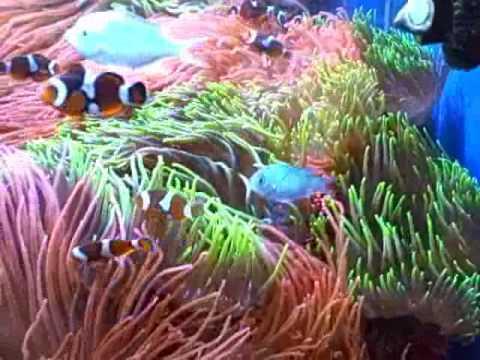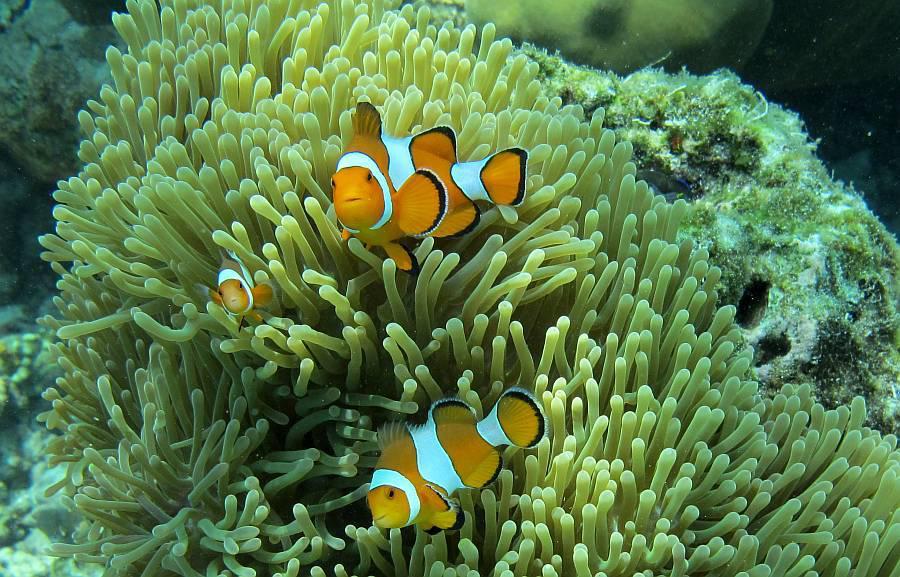The first image is the image on the left, the second image is the image on the right. For the images displayed, is the sentence "At least 2 clown fish are swimming near a large sea urchin." factually correct? Answer yes or no. Yes. The first image is the image on the left, the second image is the image on the right. Given the left and right images, does the statement "One image shows a single prominent clownfish with head and body facing left, in front of neutral-colored anemone tendrils." hold true? Answer yes or no. No. 